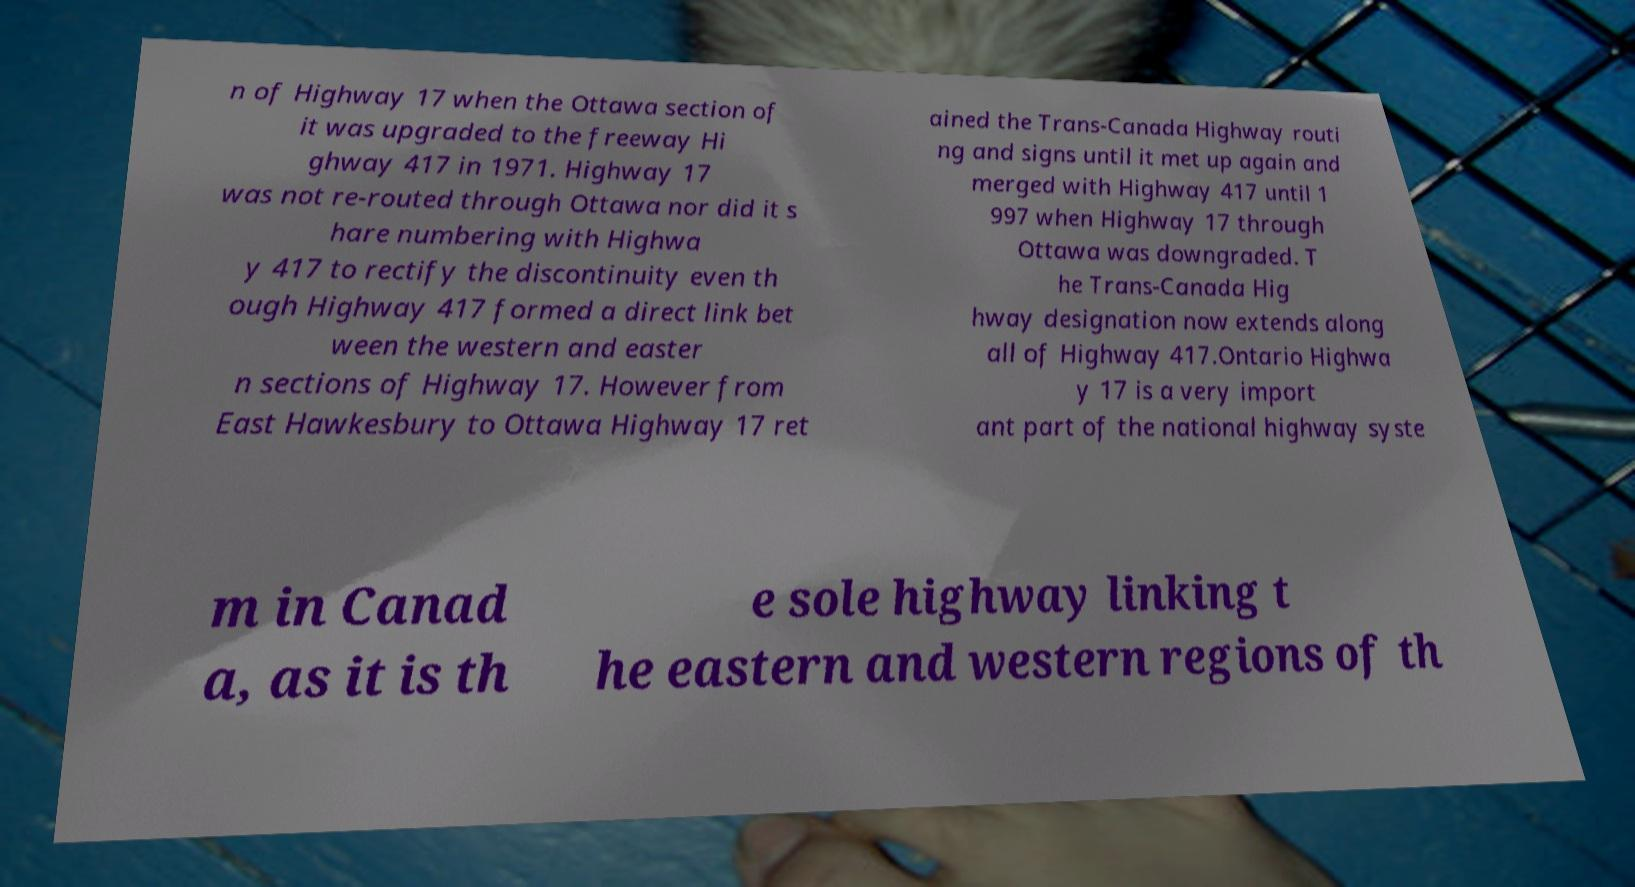There's text embedded in this image that I need extracted. Can you transcribe it verbatim? n of Highway 17 when the Ottawa section of it was upgraded to the freeway Hi ghway 417 in 1971. Highway 17 was not re-routed through Ottawa nor did it s hare numbering with Highwa y 417 to rectify the discontinuity even th ough Highway 417 formed a direct link bet ween the western and easter n sections of Highway 17. However from East Hawkesbury to Ottawa Highway 17 ret ained the Trans-Canada Highway routi ng and signs until it met up again and merged with Highway 417 until 1 997 when Highway 17 through Ottawa was downgraded. T he Trans-Canada Hig hway designation now extends along all of Highway 417.Ontario Highwa y 17 is a very import ant part of the national highway syste m in Canad a, as it is th e sole highway linking t he eastern and western regions of th 